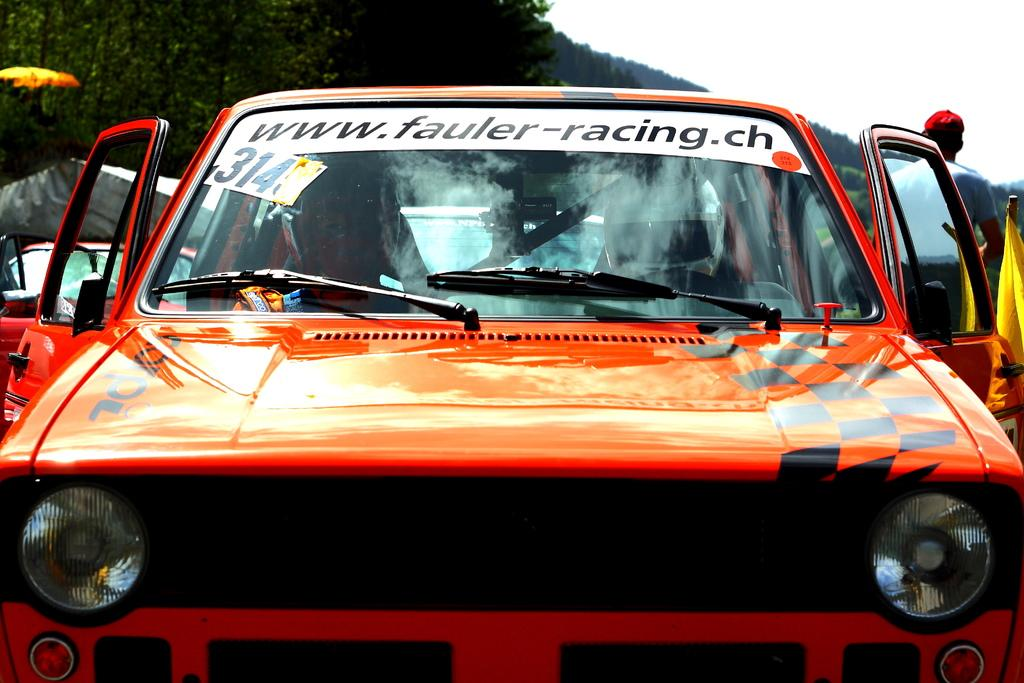What can be seen in the image besides the person standing to the right? There are vehicles in the image. Can you describe the person standing to the right? The person is wearing a dress and cap. What is visible in the background of the image? There are many trees and the sky in the background of the image. What type of exchange is taking place between the person and the vehicles in the image? There is no exchange taking place between the person and the vehicles in the image. Can you see a basketball being played in the image? There is no basketball or any indication of a game being played in the image. 